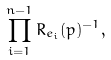<formula> <loc_0><loc_0><loc_500><loc_500>\prod _ { i = 1 } ^ { n - 1 } R _ { e _ { i } } ( p ) ^ { - 1 } ,</formula> 